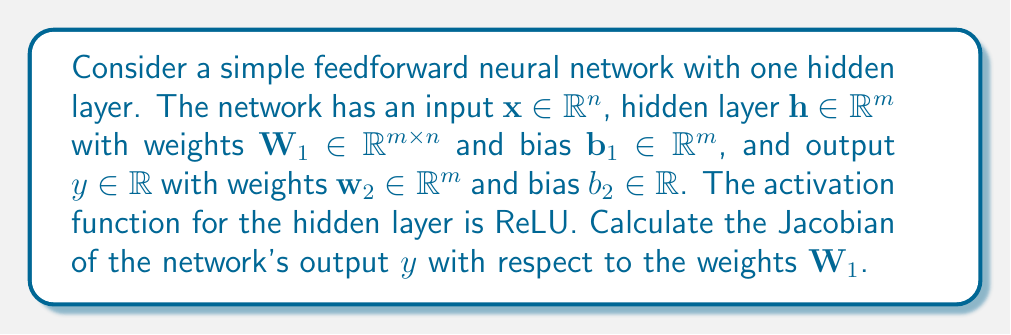Provide a solution to this math problem. Let's approach this step-by-step:

1) First, let's write out the equations for the network:

   $$\mathbf{h} = \text{ReLU}(\mathbf{W}_1\mathbf{x} + \mathbf{b}_1)$$
   $$y = \mathbf{w}_2^T\mathbf{h} + b_2$$

2) The Jacobian we want to calculate is $\frac{\partial y}{\partial \mathbf{W}_1}$. We can use the chain rule:

   $$\frac{\partial y}{\partial \mathbf{W}_1} = \frac{\partial y}{\partial \mathbf{h}} \frac{\partial \mathbf{h}}{\partial \mathbf{W}_1}$$

3) Let's calculate $\frac{\partial y}{\partial \mathbf{h}}$ first:

   $$\frac{\partial y}{\partial \mathbf{h}} = \mathbf{w}_2^T$$

4) Now, let's calculate $\frac{\partial \mathbf{h}}{\partial \mathbf{W}_1}$. This is trickier because of the ReLU function. Let's define:

   $$\mathbf{z} = \mathbf{W}_1\mathbf{x} + \mathbf{b}_1$$

   Then $\mathbf{h} = \text{ReLU}(\mathbf{z})$, and we can use the chain rule again:

   $$\frac{\partial \mathbf{h}}{\partial \mathbf{W}_1} = \frac{\partial \mathbf{h}}{\partial \mathbf{z}} \frac{\partial \mathbf{z}}{\partial \mathbf{W}_1}$$

5) $\frac{\partial \mathbf{h}}{\partial \mathbf{z}}$ is the derivative of ReLU, which is a diagonal matrix:

   $$\frac{\partial \mathbf{h}}{\partial \mathbf{z}} = \text{diag}(\mathbb{1}_{\mathbf{z} > 0})$$

   where $\mathbb{1}_{\mathbf{z} > 0}$ is an indicator function that is 1 where $\mathbf{z} > 0$ and 0 otherwise.

6) $\frac{\partial \mathbf{z}}{\partial \mathbf{W}_1}$ is simply $\mathbf{x}^T$, repeated $m$ times (once for each row of $\mathbf{W}_1$).

7) Putting it all together:

   $$\frac{\partial y}{\partial \mathbf{W}_1} = \mathbf{w}_2^T \text{diag}(\mathbb{1}_{\mathbf{z} > 0}) \mathbf{x}^T$$

8) This results in a matrix of shape $m \times n$, which matches the shape of $\mathbf{W}_1$.
Answer: $$\frac{\partial y}{\partial \mathbf{W}_1} = \mathbf{w}_2^T \text{diag}(\mathbb{1}_{\mathbf{z} > 0}) \mathbf{x}^T$$ 